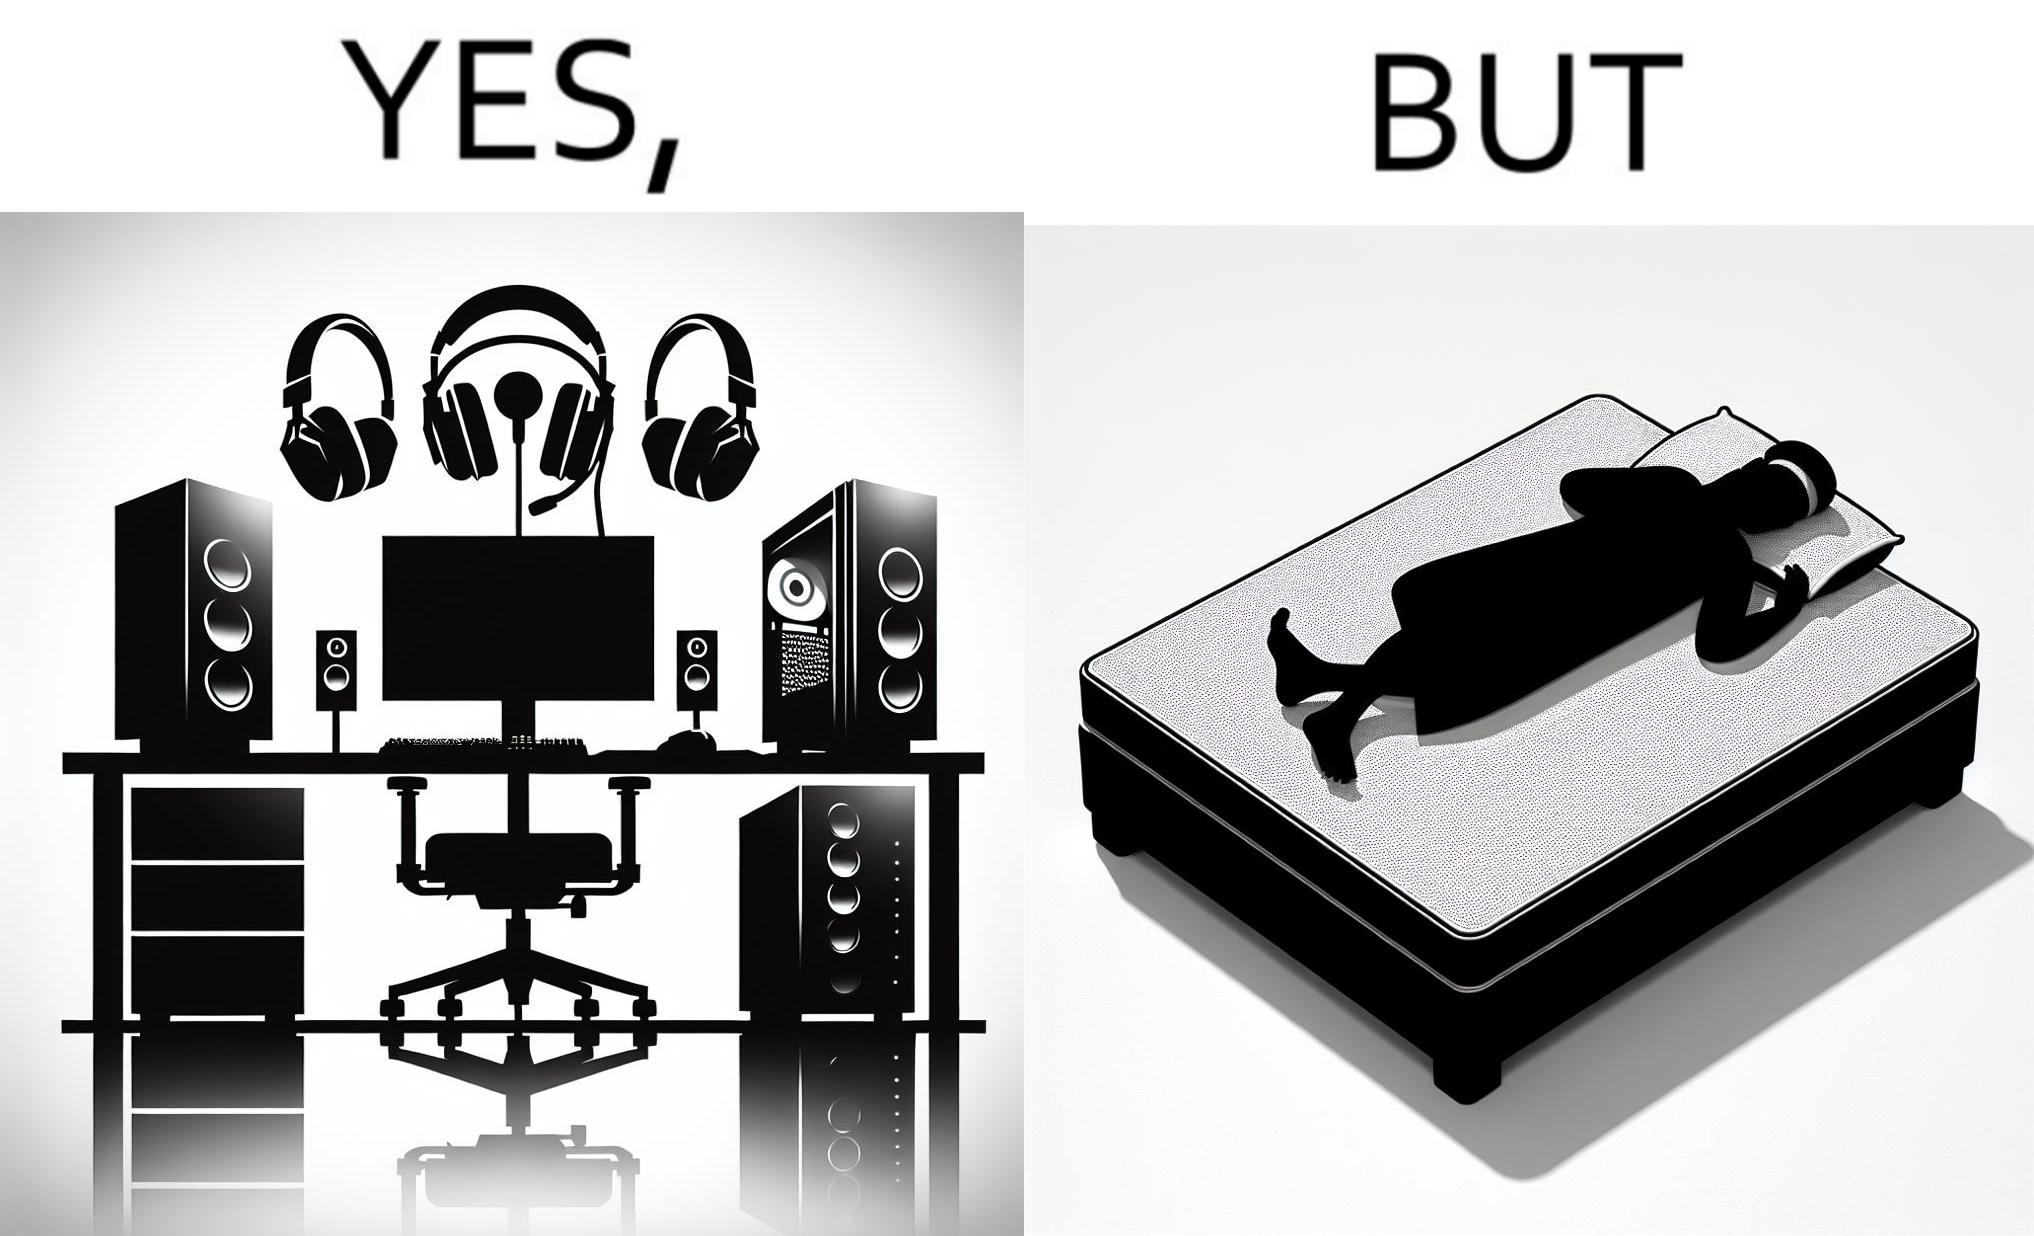What does this image depict? The image is funny because the person has a lot of furniture for his computer but none for himself. 